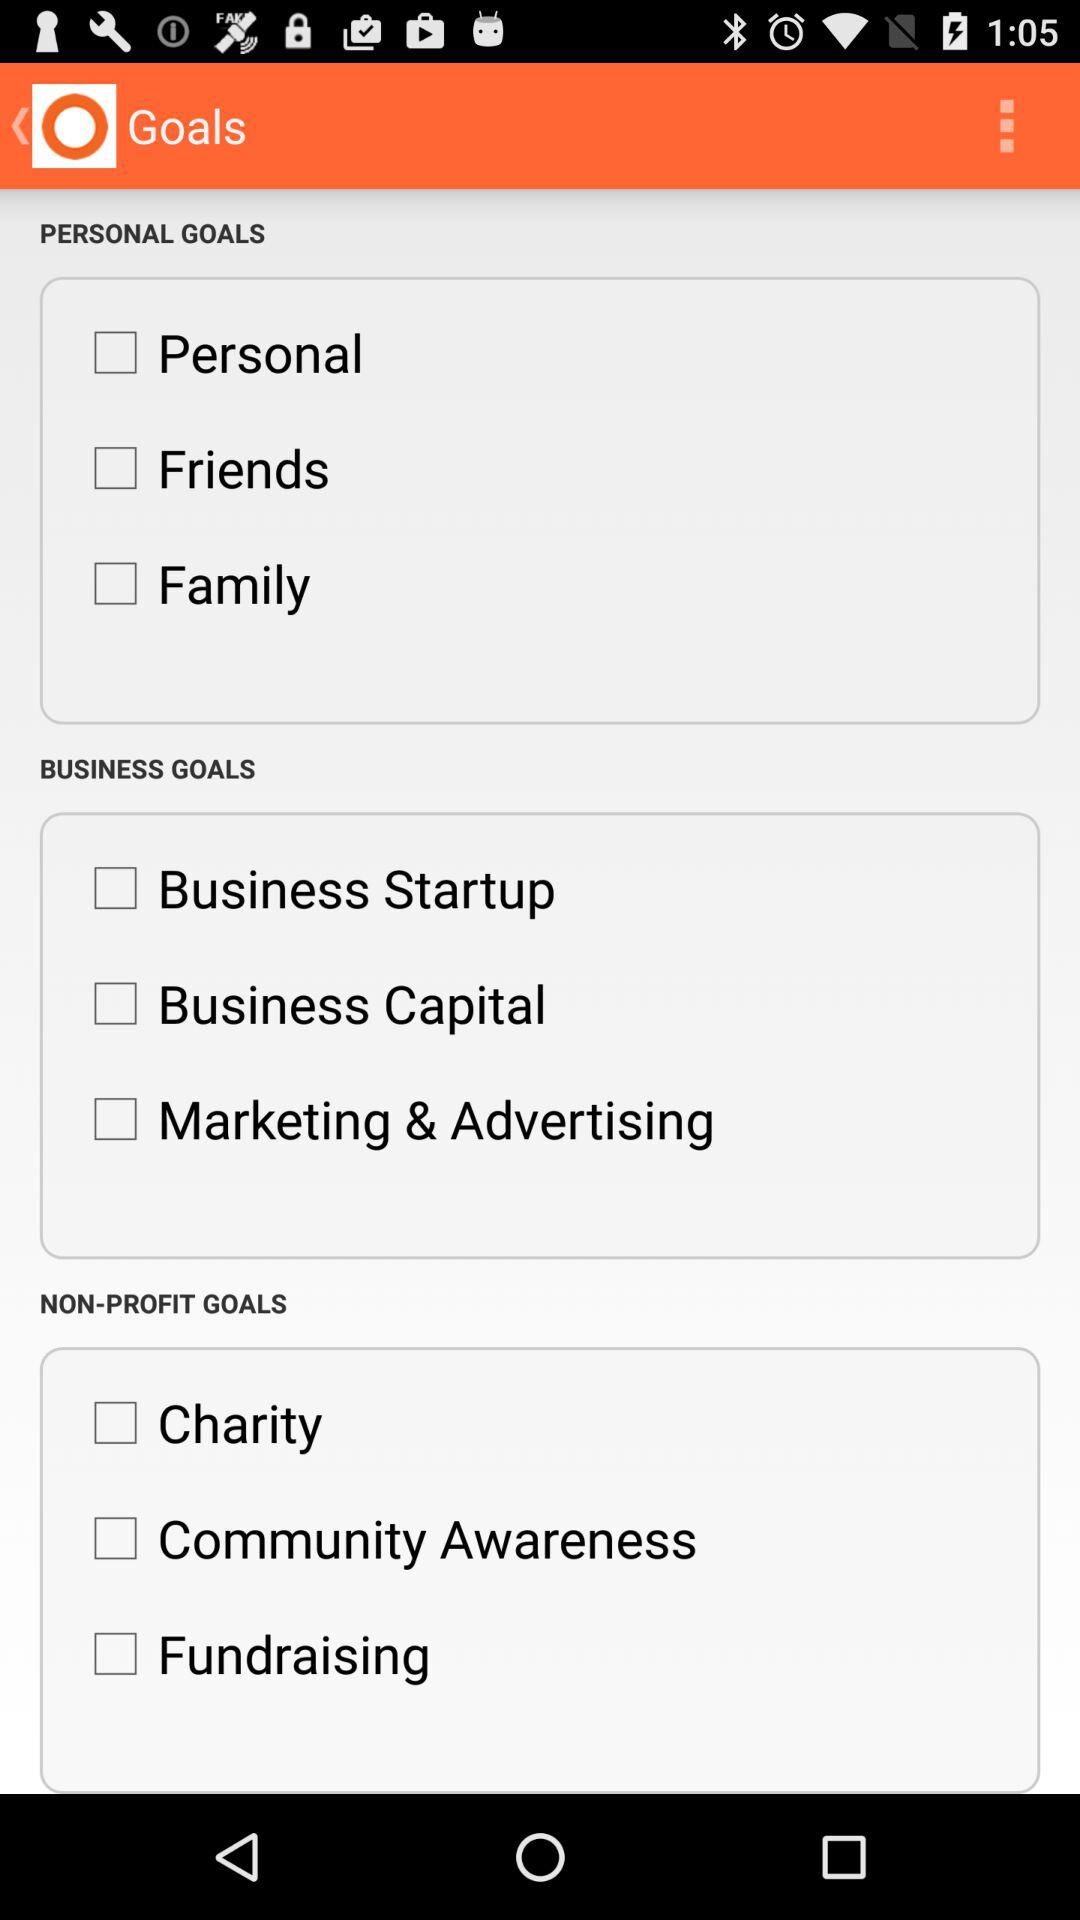What are the options in "PERSONAL GOALS"? The options are "Personal", "Friends" and "Family". 